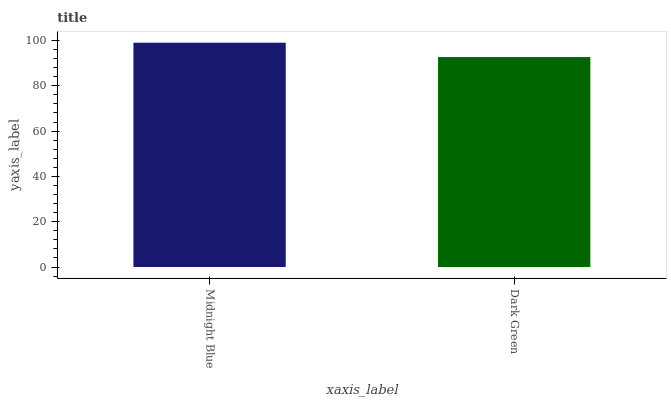Is Dark Green the maximum?
Answer yes or no. No. Is Midnight Blue greater than Dark Green?
Answer yes or no. Yes. Is Dark Green less than Midnight Blue?
Answer yes or no. Yes. Is Dark Green greater than Midnight Blue?
Answer yes or no. No. Is Midnight Blue less than Dark Green?
Answer yes or no. No. Is Midnight Blue the high median?
Answer yes or no. Yes. Is Dark Green the low median?
Answer yes or no. Yes. Is Dark Green the high median?
Answer yes or no. No. Is Midnight Blue the low median?
Answer yes or no. No. 